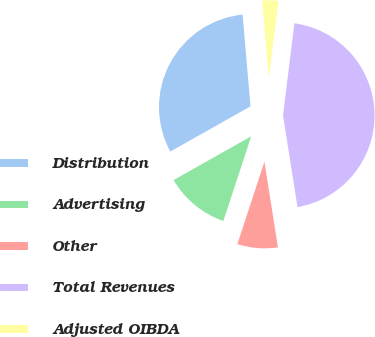Convert chart. <chart><loc_0><loc_0><loc_500><loc_500><pie_chart><fcel>Distribution<fcel>Advertising<fcel>Other<fcel>Total Revenues<fcel>Adjusted OIBDA<nl><fcel>31.81%<fcel>11.77%<fcel>7.55%<fcel>45.55%<fcel>3.32%<nl></chart> 